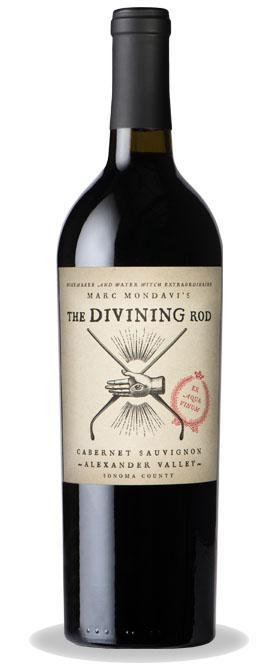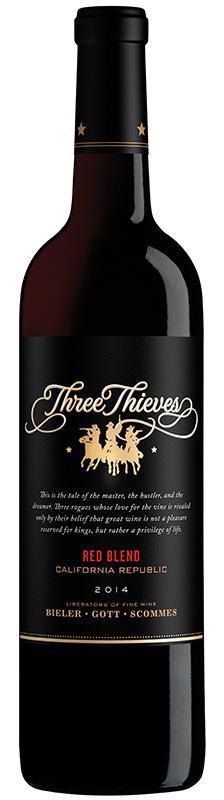The first image is the image on the left, the second image is the image on the right. Evaluate the accuracy of this statement regarding the images: "The label of the bottle of red wine has the words Three Thieves in gold writing.". Is it true? Answer yes or no. Yes. The first image is the image on the left, the second image is the image on the right. Analyze the images presented: Is the assertion "The combined images include at least two wine bottles with white-background labels." valid? Answer yes or no. No. 